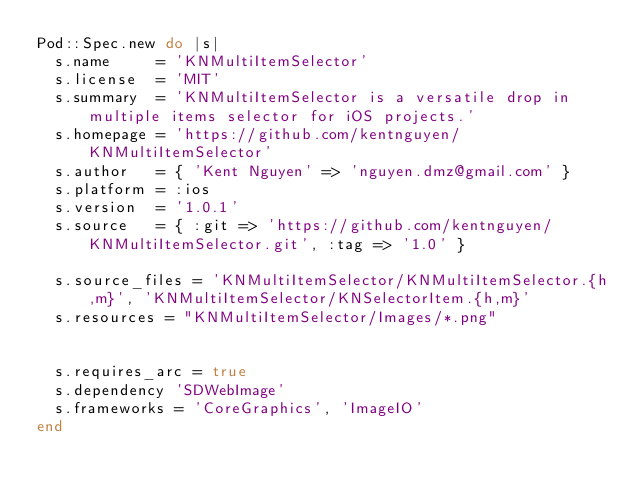<code> <loc_0><loc_0><loc_500><loc_500><_Ruby_>Pod::Spec.new do |s|
  s.name     = 'KNMultiItemSelector'
  s.license  = 'MIT'
  s.summary  = 'KNMultiItemSelector is a versatile drop in multiple items selector for iOS projects.'
  s.homepage = 'https://github.com/kentnguyen/KNMultiItemSelector'
  s.author   = { 'Kent Nguyen' => 'nguyen.dmz@gmail.com' }
  s.platform = :ios
  s.version  = '1.0.1'
  s.source   = { :git => 'https://github.com/kentnguyen/KNMultiItemSelector.git', :tag => '1.0' }

  s.source_files = 'KNMultiItemSelector/KNMultiItemSelector.{h,m}', 'KNMultiItemSelector/KNSelectorItem.{h,m}'
  s.resources = "KNMultiItemSelector/Images/*.png"

  
  s.requires_arc = true
  s.dependency 'SDWebImage'
  s.frameworks = 'CoreGraphics', 'ImageIO'
end
</code> 